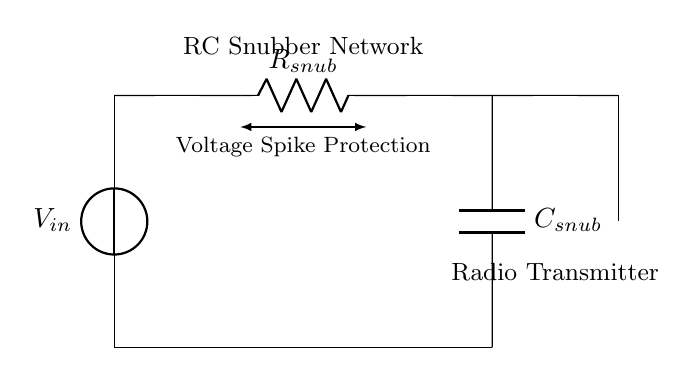What is the first component in the circuit? The first component is a voltage source, denoted as V in the circuit. It supplies the input voltage to the RC snubber network.
Answer: Voltage source What is the type of network depicted in this diagram? The diagram shows an RC snubber network, used to protect components from voltage spikes. This is indicated by the resistor and capacitor configuration connected to the input voltage.
Answer: RC snubber network What components are included in the snubber circuit? The snubber circuit includes a resistor (R) and a capacitor (C), which are connected in series. This combination is essential for voltage spike suppression.
Answer: Resistor and capacitor What does the arrow between the resistor and the capacitor indicate? The arrow signifies the function of the RC snubber network, which is to provide voltage spike protection. This means the components work together to limit transient voltages.
Answer: Voltage spike protection What is connected to the output of the RC snubber network? The output of the RC snubber network is connected to an antenna, which indicates that the circuit is likely part of a radio transmitter setup.
Answer: Antenna How does the capacitor affect the circuit during a voltage spike? The capacitor absorbs the excess voltage during a spike, thereby preventing it from affecting the circuit further down, such as the radio transmitter components. It smooths out transient voltage changes.
Answer: Absorbs excess voltage What role does the resistor play in this circuit? The resistor limits the current flowing through the capacitor, which helps to dissipate energy and manage the rate of voltage change across the circuit components during a transient event.
Answer: Limits current 